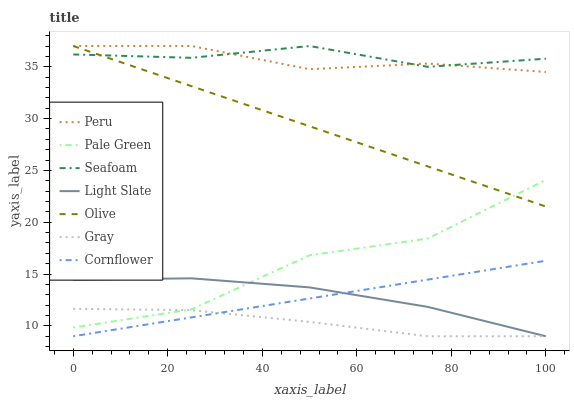Does Cornflower have the minimum area under the curve?
Answer yes or no. No. Does Cornflower have the maximum area under the curve?
Answer yes or no. No. Is Light Slate the smoothest?
Answer yes or no. No. Is Light Slate the roughest?
Answer yes or no. No. Does Seafoam have the lowest value?
Answer yes or no. No. Does Cornflower have the highest value?
Answer yes or no. No. Is Cornflower less than Pale Green?
Answer yes or no. Yes. Is Seafoam greater than Cornflower?
Answer yes or no. Yes. Does Cornflower intersect Pale Green?
Answer yes or no. No. 